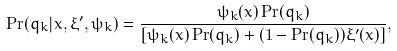Convert formula to latex. <formula><loc_0><loc_0><loc_500><loc_500>\Pr ( q _ { k } | x , \xi ^ { \prime } , \psi _ { k } ) = \frac { \psi _ { k } ( x ) \Pr ( q _ { k } ) } { [ \psi _ { k } ( x ) \Pr ( q _ { k } ) + ( 1 - \Pr ( q _ { k } ) ) \xi ^ { \prime } ( x ) ] } ,</formula> 